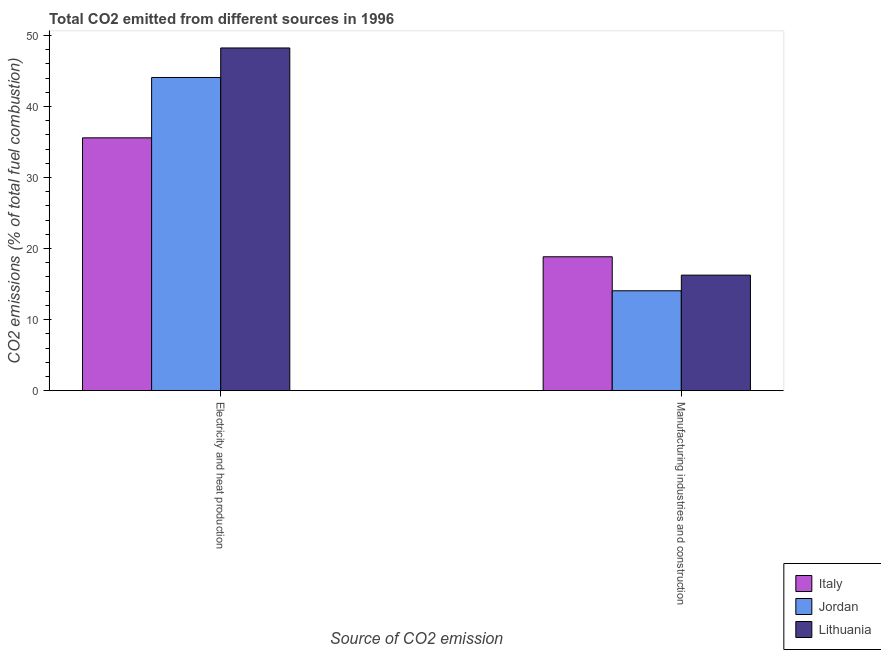How many different coloured bars are there?
Provide a short and direct response. 3. How many groups of bars are there?
Offer a very short reply. 2. How many bars are there on the 1st tick from the right?
Offer a very short reply. 3. What is the label of the 2nd group of bars from the left?
Keep it short and to the point. Manufacturing industries and construction. What is the co2 emissions due to electricity and heat production in Jordan?
Offer a terse response. 44.08. Across all countries, what is the maximum co2 emissions due to manufacturing industries?
Provide a short and direct response. 18.84. Across all countries, what is the minimum co2 emissions due to electricity and heat production?
Keep it short and to the point. 35.59. In which country was the co2 emissions due to electricity and heat production minimum?
Provide a succinct answer. Italy. What is the total co2 emissions due to manufacturing industries in the graph?
Ensure brevity in your answer.  49.16. What is the difference between the co2 emissions due to electricity and heat production in Jordan and that in Lithuania?
Your response must be concise. -4.16. What is the difference between the co2 emissions due to electricity and heat production in Jordan and the co2 emissions due to manufacturing industries in Lithuania?
Your answer should be compact. 27.82. What is the average co2 emissions due to electricity and heat production per country?
Offer a terse response. 42.64. What is the difference between the co2 emissions due to electricity and heat production and co2 emissions due to manufacturing industries in Jordan?
Your answer should be very brief. 30.02. What is the ratio of the co2 emissions due to electricity and heat production in Italy to that in Lithuania?
Offer a terse response. 0.74. In how many countries, is the co2 emissions due to manufacturing industries greater than the average co2 emissions due to manufacturing industries taken over all countries?
Your response must be concise. 1. What does the 2nd bar from the left in Manufacturing industries and construction represents?
Your answer should be compact. Jordan. What does the 2nd bar from the right in Electricity and heat production represents?
Your response must be concise. Jordan. How many bars are there?
Provide a short and direct response. 6. Are all the bars in the graph horizontal?
Ensure brevity in your answer.  No. How many countries are there in the graph?
Ensure brevity in your answer.  3. Does the graph contain any zero values?
Your answer should be compact. No. Does the graph contain grids?
Your answer should be compact. No. How many legend labels are there?
Your answer should be compact. 3. How are the legend labels stacked?
Make the answer very short. Vertical. What is the title of the graph?
Keep it short and to the point. Total CO2 emitted from different sources in 1996. What is the label or title of the X-axis?
Offer a terse response. Source of CO2 emission. What is the label or title of the Y-axis?
Offer a terse response. CO2 emissions (% of total fuel combustion). What is the CO2 emissions (% of total fuel combustion) in Italy in Electricity and heat production?
Your answer should be compact. 35.59. What is the CO2 emissions (% of total fuel combustion) in Jordan in Electricity and heat production?
Your answer should be very brief. 44.08. What is the CO2 emissions (% of total fuel combustion) of Lithuania in Electricity and heat production?
Provide a succinct answer. 48.24. What is the CO2 emissions (% of total fuel combustion) of Italy in Manufacturing industries and construction?
Your answer should be compact. 18.84. What is the CO2 emissions (% of total fuel combustion) of Jordan in Manufacturing industries and construction?
Ensure brevity in your answer.  14.06. What is the CO2 emissions (% of total fuel combustion) in Lithuania in Manufacturing industries and construction?
Offer a very short reply. 16.26. Across all Source of CO2 emission, what is the maximum CO2 emissions (% of total fuel combustion) in Italy?
Give a very brief answer. 35.59. Across all Source of CO2 emission, what is the maximum CO2 emissions (% of total fuel combustion) in Jordan?
Your answer should be very brief. 44.08. Across all Source of CO2 emission, what is the maximum CO2 emissions (% of total fuel combustion) in Lithuania?
Keep it short and to the point. 48.24. Across all Source of CO2 emission, what is the minimum CO2 emissions (% of total fuel combustion) in Italy?
Provide a succinct answer. 18.84. Across all Source of CO2 emission, what is the minimum CO2 emissions (% of total fuel combustion) in Jordan?
Provide a short and direct response. 14.06. Across all Source of CO2 emission, what is the minimum CO2 emissions (% of total fuel combustion) of Lithuania?
Provide a succinct answer. 16.26. What is the total CO2 emissions (% of total fuel combustion) in Italy in the graph?
Keep it short and to the point. 54.43. What is the total CO2 emissions (% of total fuel combustion) in Jordan in the graph?
Your response must be concise. 58.14. What is the total CO2 emissions (% of total fuel combustion) of Lithuania in the graph?
Give a very brief answer. 64.5. What is the difference between the CO2 emissions (% of total fuel combustion) of Italy in Electricity and heat production and that in Manufacturing industries and construction?
Keep it short and to the point. 16.74. What is the difference between the CO2 emissions (% of total fuel combustion) of Jordan in Electricity and heat production and that in Manufacturing industries and construction?
Your answer should be compact. 30.02. What is the difference between the CO2 emissions (% of total fuel combustion) of Lithuania in Electricity and heat production and that in Manufacturing industries and construction?
Your answer should be very brief. 31.98. What is the difference between the CO2 emissions (% of total fuel combustion) in Italy in Electricity and heat production and the CO2 emissions (% of total fuel combustion) in Jordan in Manufacturing industries and construction?
Your response must be concise. 21.53. What is the difference between the CO2 emissions (% of total fuel combustion) in Italy in Electricity and heat production and the CO2 emissions (% of total fuel combustion) in Lithuania in Manufacturing industries and construction?
Provide a short and direct response. 19.33. What is the difference between the CO2 emissions (% of total fuel combustion) of Jordan in Electricity and heat production and the CO2 emissions (% of total fuel combustion) of Lithuania in Manufacturing industries and construction?
Offer a terse response. 27.82. What is the average CO2 emissions (% of total fuel combustion) in Italy per Source of CO2 emission?
Provide a succinct answer. 27.22. What is the average CO2 emissions (% of total fuel combustion) in Jordan per Source of CO2 emission?
Offer a terse response. 29.07. What is the average CO2 emissions (% of total fuel combustion) of Lithuania per Source of CO2 emission?
Provide a succinct answer. 32.25. What is the difference between the CO2 emissions (% of total fuel combustion) of Italy and CO2 emissions (% of total fuel combustion) of Jordan in Electricity and heat production?
Keep it short and to the point. -8.5. What is the difference between the CO2 emissions (% of total fuel combustion) in Italy and CO2 emissions (% of total fuel combustion) in Lithuania in Electricity and heat production?
Give a very brief answer. -12.65. What is the difference between the CO2 emissions (% of total fuel combustion) of Jordan and CO2 emissions (% of total fuel combustion) of Lithuania in Electricity and heat production?
Provide a succinct answer. -4.16. What is the difference between the CO2 emissions (% of total fuel combustion) in Italy and CO2 emissions (% of total fuel combustion) in Jordan in Manufacturing industries and construction?
Your response must be concise. 4.79. What is the difference between the CO2 emissions (% of total fuel combustion) in Italy and CO2 emissions (% of total fuel combustion) in Lithuania in Manufacturing industries and construction?
Ensure brevity in your answer.  2.58. What is the difference between the CO2 emissions (% of total fuel combustion) in Jordan and CO2 emissions (% of total fuel combustion) in Lithuania in Manufacturing industries and construction?
Make the answer very short. -2.2. What is the ratio of the CO2 emissions (% of total fuel combustion) in Italy in Electricity and heat production to that in Manufacturing industries and construction?
Keep it short and to the point. 1.89. What is the ratio of the CO2 emissions (% of total fuel combustion) of Jordan in Electricity and heat production to that in Manufacturing industries and construction?
Keep it short and to the point. 3.14. What is the ratio of the CO2 emissions (% of total fuel combustion) of Lithuania in Electricity and heat production to that in Manufacturing industries and construction?
Provide a succinct answer. 2.97. What is the difference between the highest and the second highest CO2 emissions (% of total fuel combustion) of Italy?
Keep it short and to the point. 16.74. What is the difference between the highest and the second highest CO2 emissions (% of total fuel combustion) in Jordan?
Your answer should be very brief. 30.02. What is the difference between the highest and the second highest CO2 emissions (% of total fuel combustion) in Lithuania?
Provide a short and direct response. 31.98. What is the difference between the highest and the lowest CO2 emissions (% of total fuel combustion) in Italy?
Your answer should be compact. 16.74. What is the difference between the highest and the lowest CO2 emissions (% of total fuel combustion) of Jordan?
Offer a terse response. 30.02. What is the difference between the highest and the lowest CO2 emissions (% of total fuel combustion) of Lithuania?
Make the answer very short. 31.98. 